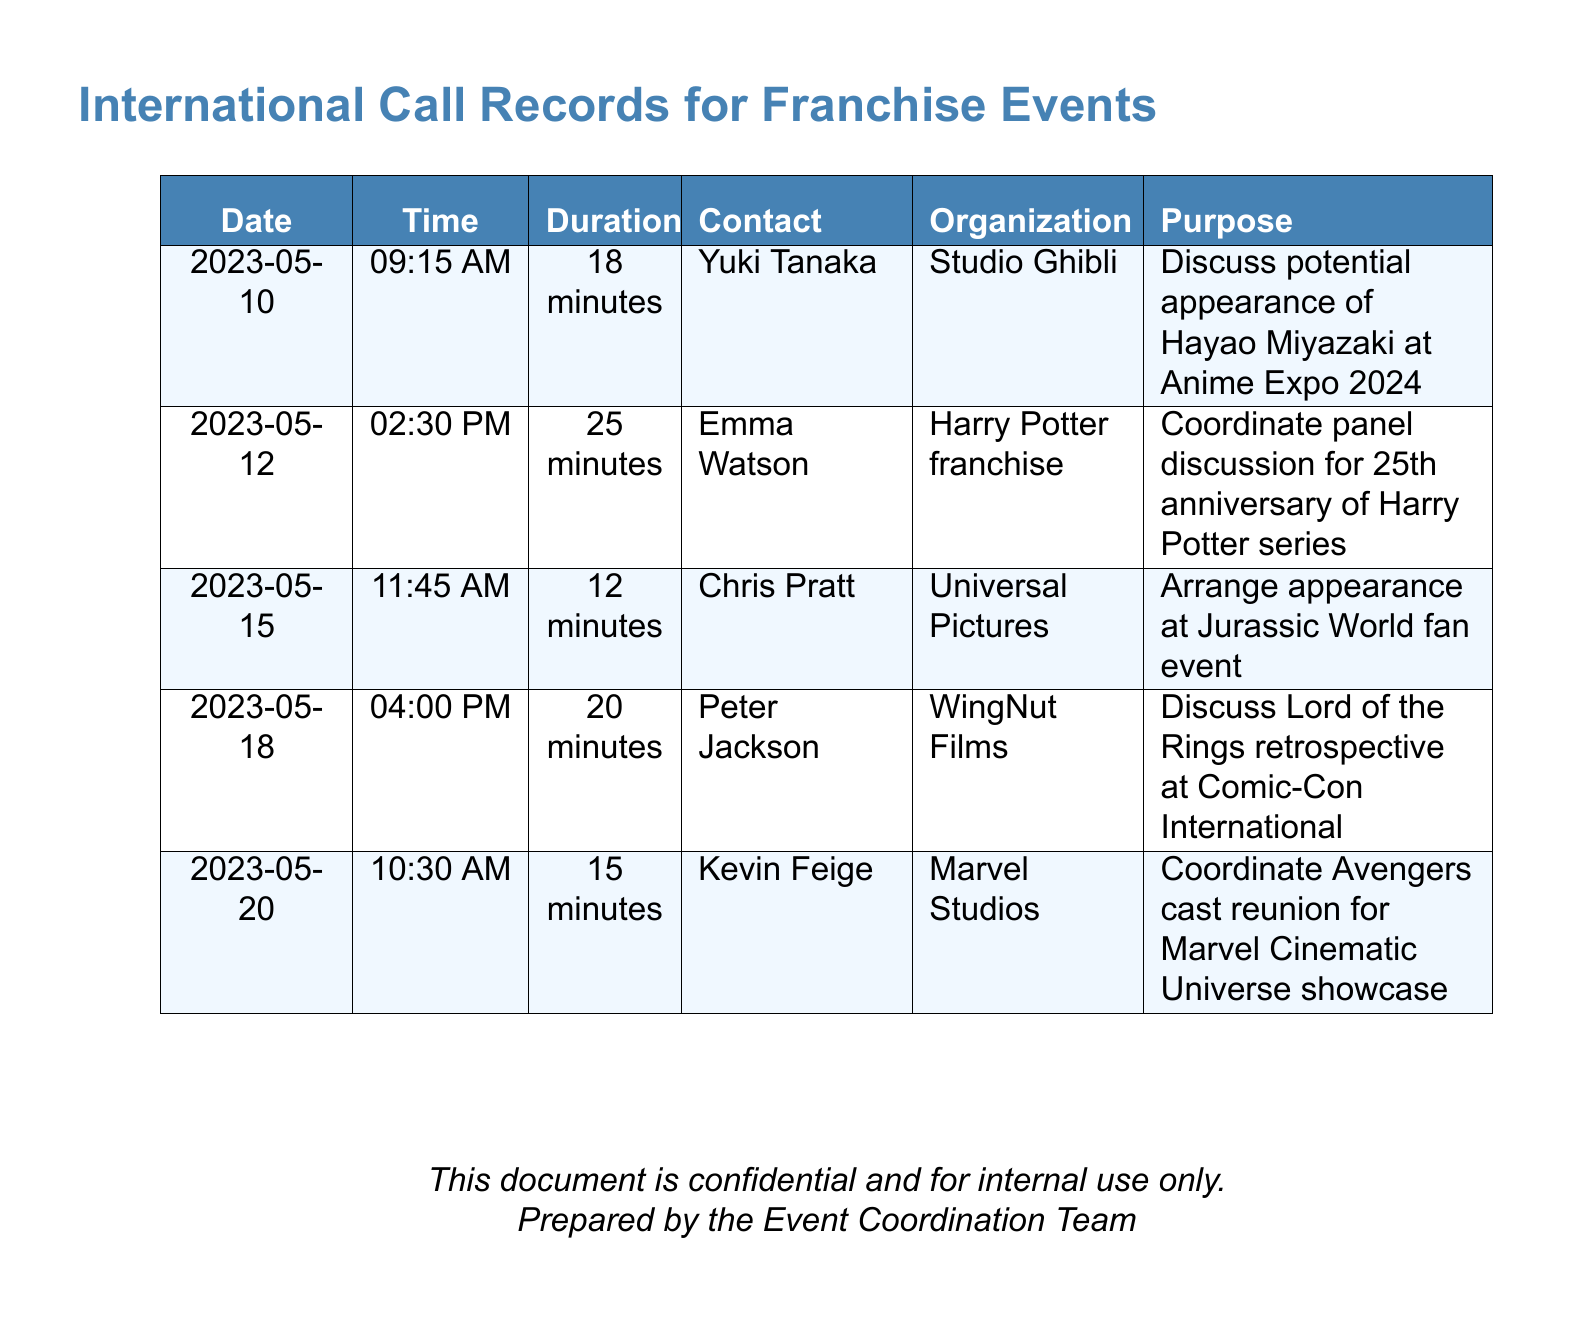What is the date of the call with Yuki Tanaka? The document records the date of the call with Yuki Tanaka as May 10, 2023.
Answer: May 10, 2023 How long was the call with Chris Pratt? The duration of the call with Chris Pratt is listed as 12 minutes.
Answer: 12 minutes Who is the contact for the Harry Potter franchise? The contact person listed for the Harry Potter franchise is Emma Watson.
Answer: Emma Watson What is the purpose of the call with Peter Jackson? The purpose mentioned for the call with Peter Jackson is to discuss a Lord of the Rings retrospective at Comic-Con International.
Answer: Discuss Lord of the Rings retrospective at Comic-Con International How many calls were made to studio representatives in May 2023? There are four distinct calls recorded to studio representatives made in May 2023.
Answer: 4 Which organization is associated with the potential appearance of Hayao Miyazaki? The organization associated with Hayao Miyazaki's potential appearance is Studio Ghibli.
Answer: Studio Ghibli What was discussed in the call with Kevin Feige? The discussion in the call with Kevin Feige was about coordinating an Avengers cast reunion.
Answer: Coordinate Avengers cast reunion What time was the call with Emma Watson? The time of the call with Emma Watson was at 2:30 PM.
Answer: 2:30 PM 